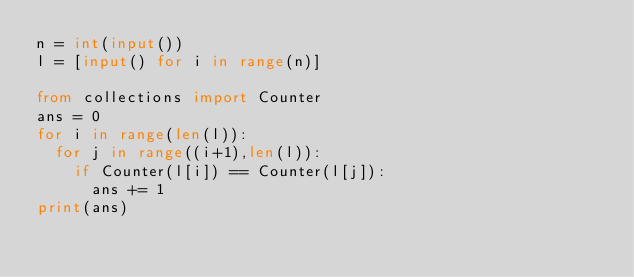<code> <loc_0><loc_0><loc_500><loc_500><_Python_>n = int(input())
l = [input() for i in range(n)]

from collections import Counter
ans = 0
for i in range(len(l)):
  for j in range((i+1),len(l)):
    if Counter(l[i]) == Counter(l[j]):
      ans += 1
print(ans)</code> 